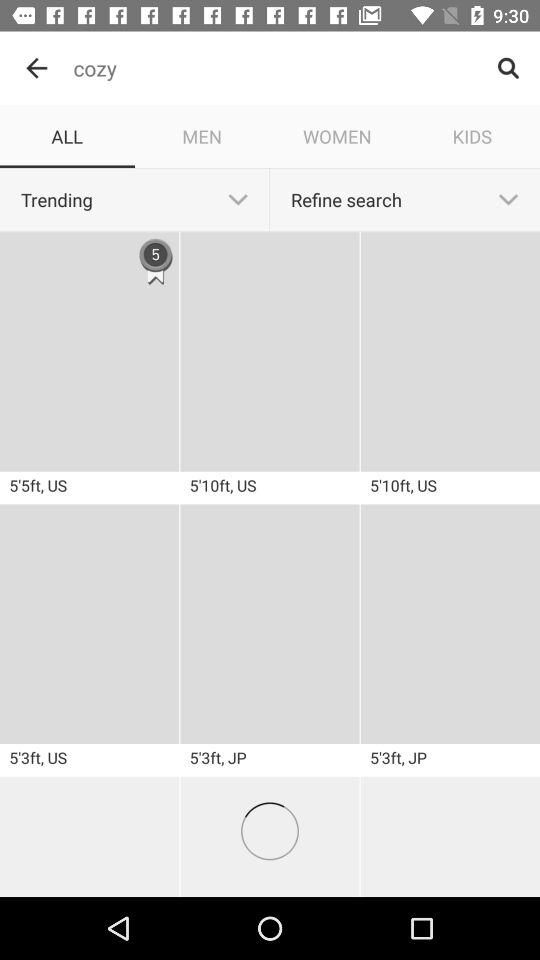What is the number shown on 5'5ft, US? The shown number is 5. 